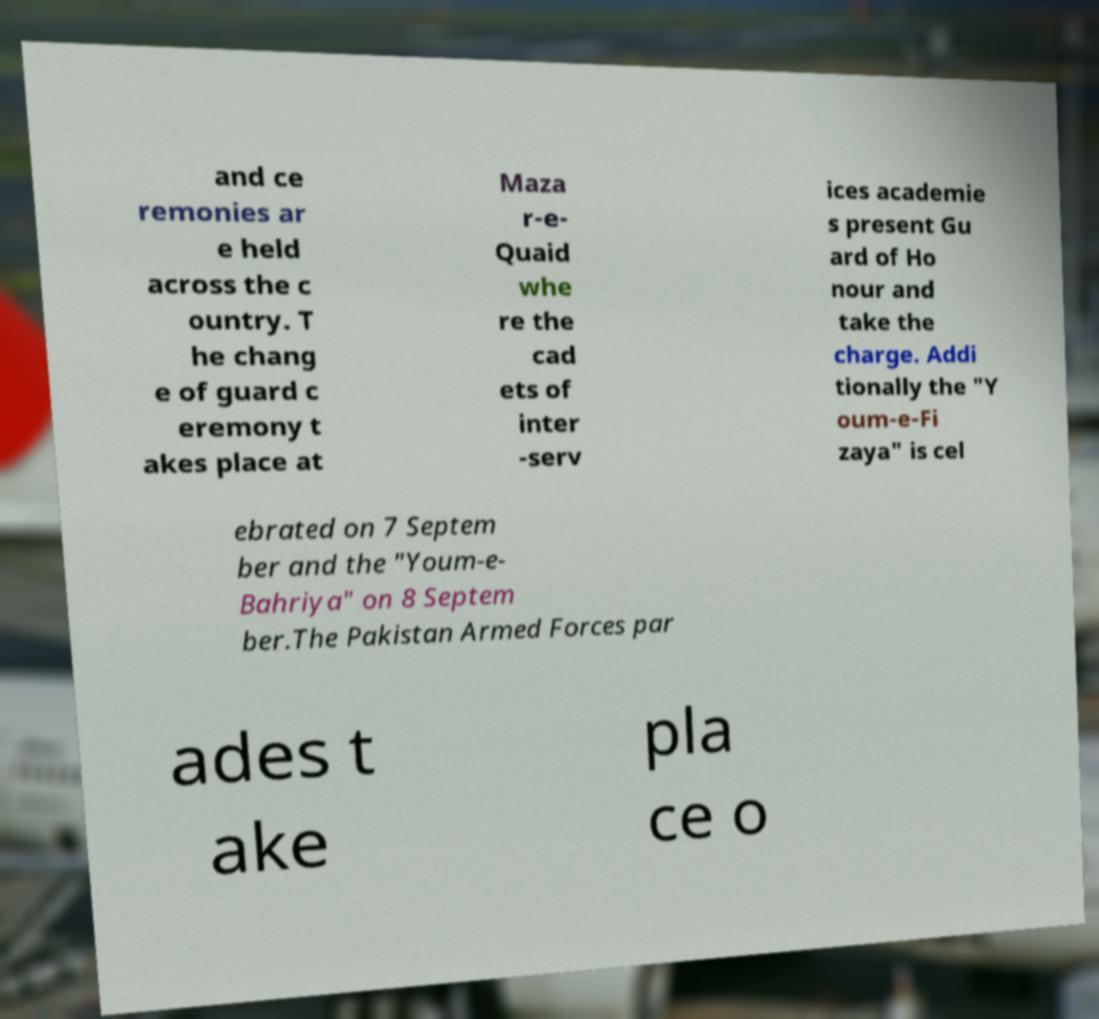Could you assist in decoding the text presented in this image and type it out clearly? and ce remonies ar e held across the c ountry. T he chang e of guard c eremony t akes place at Maza r-e- Quaid whe re the cad ets of inter -serv ices academie s present Gu ard of Ho nour and take the charge. Addi tionally the "Y oum-e-Fi zaya" is cel ebrated on 7 Septem ber and the "Youm-e- Bahriya" on 8 Septem ber.The Pakistan Armed Forces par ades t ake pla ce o 